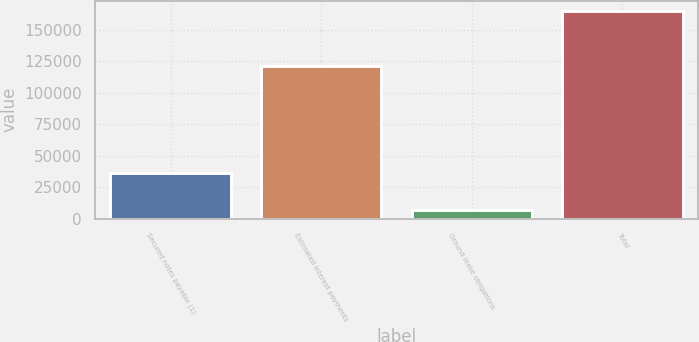Convert chart to OTSL. <chart><loc_0><loc_0><loc_500><loc_500><bar_chart><fcel>Secured notes payable (1)<fcel>Estimated interest payments<fcel>Ground lease obligations<fcel>Total<nl><fcel>35982<fcel>120955<fcel>6558<fcel>164852<nl></chart> 